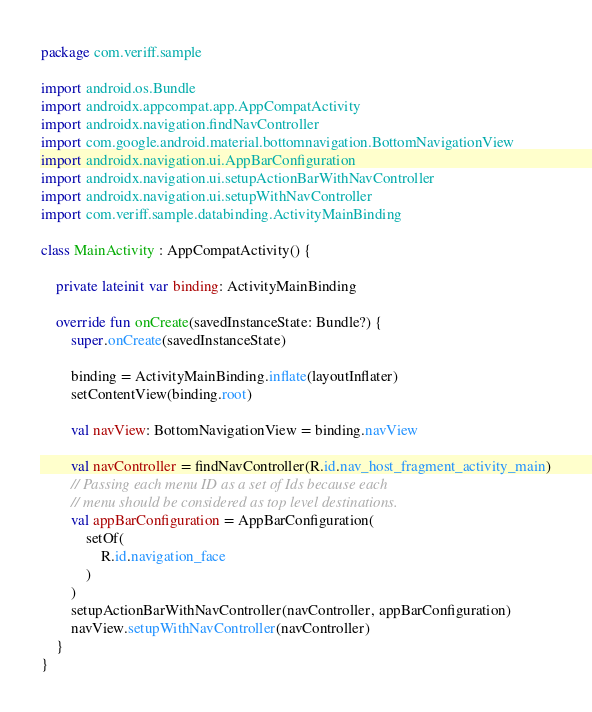Convert code to text. <code><loc_0><loc_0><loc_500><loc_500><_Kotlin_>package com.veriff.sample

import android.os.Bundle
import androidx.appcompat.app.AppCompatActivity
import androidx.navigation.findNavController
import com.google.android.material.bottomnavigation.BottomNavigationView
import androidx.navigation.ui.AppBarConfiguration
import androidx.navigation.ui.setupActionBarWithNavController
import androidx.navigation.ui.setupWithNavController
import com.veriff.sample.databinding.ActivityMainBinding

class MainActivity : AppCompatActivity() {

    private lateinit var binding: ActivityMainBinding

    override fun onCreate(savedInstanceState: Bundle?) {
        super.onCreate(savedInstanceState)

        binding = ActivityMainBinding.inflate(layoutInflater)
        setContentView(binding.root)

        val navView: BottomNavigationView = binding.navView

        val navController = findNavController(R.id.nav_host_fragment_activity_main)
        // Passing each menu ID as a set of Ids because each
        // menu should be considered as top level destinations.
        val appBarConfiguration = AppBarConfiguration(
            setOf(
                R.id.navigation_face
            )
        )
        setupActionBarWithNavController(navController, appBarConfiguration)
        navView.setupWithNavController(navController)
    }
}</code> 